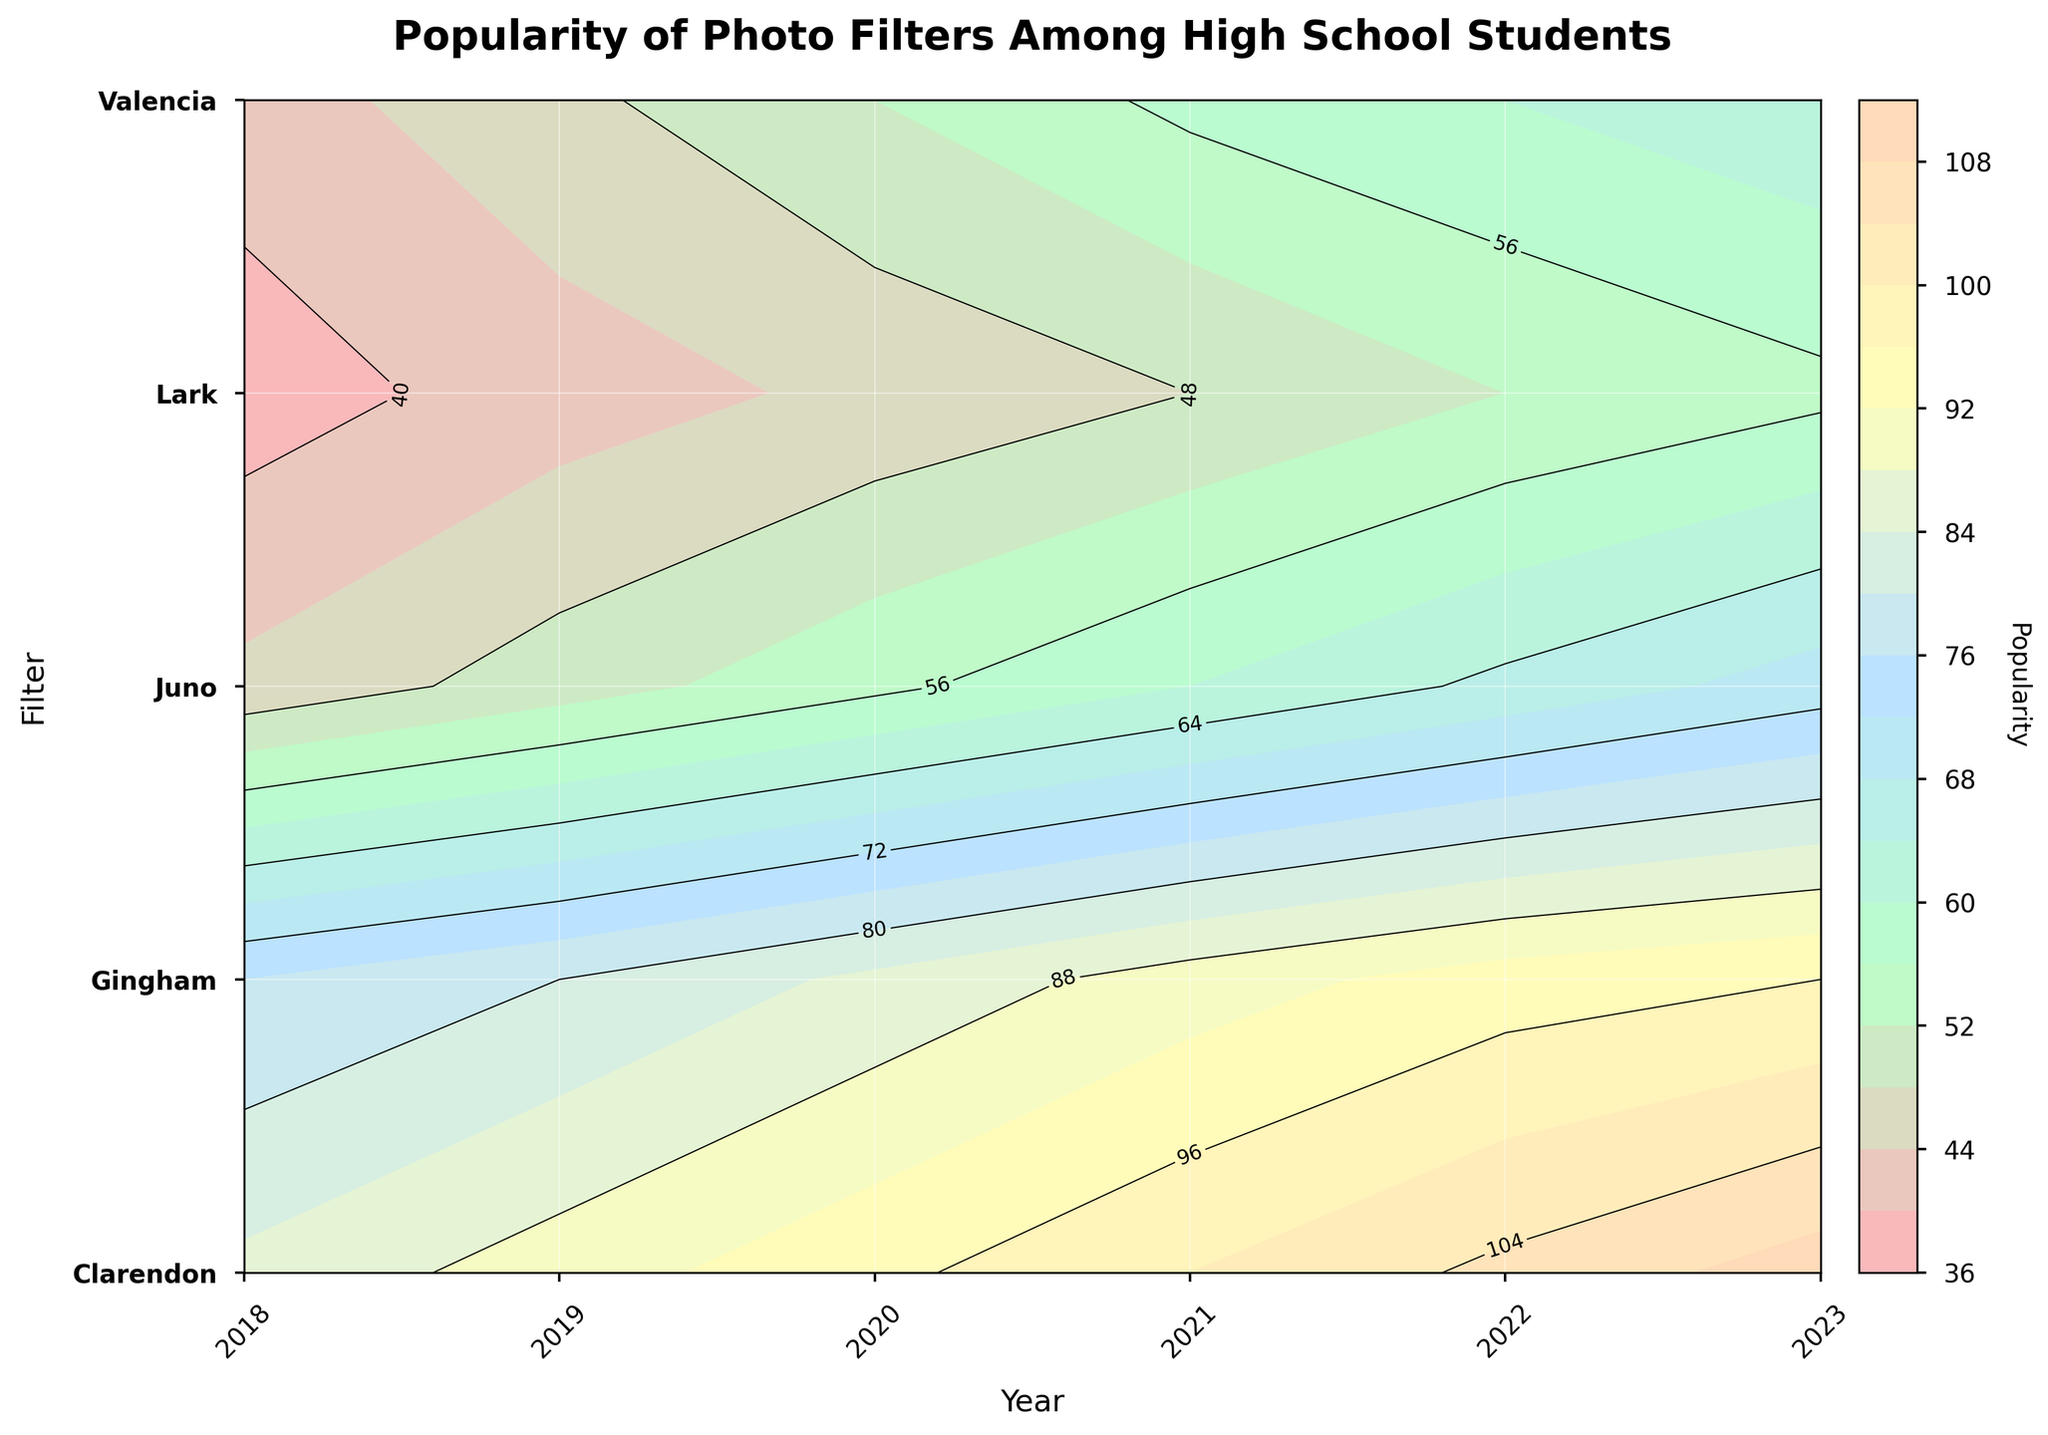What's the title of the figure? The title of the figure is located at the top and usually describes the main topic or finding represented by the plot.
Answer: Popularity of Photo Filters Among High School Students How many filters are represented in the plot? The filters are listed on the y-axis, each corresponding to a horizontal contour line. Count the number of unique labels on the y-axis to get the total number of filters.
Answer: 5 Which year shows the highest popularity for the Clarendon filter? Look at the contour labels for the Clarendon filter (highest line on the y-axis) and find the contour with the highest number.
Answer: 2023 On average, how has the popularity of the Juno filter changed over the years? Find the popularity values for Juno filter for each year, sum them up and then divide by the number of years to get the average change. (2018: 45, 2019: 50, 2020: 55, 2021: 60, 2022: 65, 2023: 70) Sum = 345, Years = 6, Average Change = 345/6
Answer: 57.5 Which filter has the lowest popularity in more than one year? Look at the contour lines, find the one that consistently has one of the lowest labels in multiple years. Compare the popularity values for all filters each year.
Answer: Lark By how much did the popularity of the Valencia filter increase from 2018 to 2023? Find the popularity value of Valencia in 2018 and 2023, and calculate the difference. 2018: 42, 2023: 63
Answer: 21 Between Gingham and Valencia, which filter had a more consistent increase in popularity over the years? Compare the contour lines representing Gingham and Valencia. A more consistent increase will have less variability in the slope of the contour line over the years.
Answer: Gingham Which year saw the largest increase in the popularity of the Clarendon filter? Look at the contour labels for the Clarendon filter and find the year where the difference between two consecutive years is the largest. Compare values from consecutive years: (2018-2019), (2019-2020), etc.
Answer: 2023 